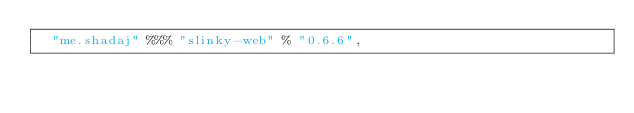Convert code to text. <code><loc_0><loc_0><loc_500><loc_500><_Scala_>  "me.shadaj" %%% "slinky-web" % "0.6.6",</code> 